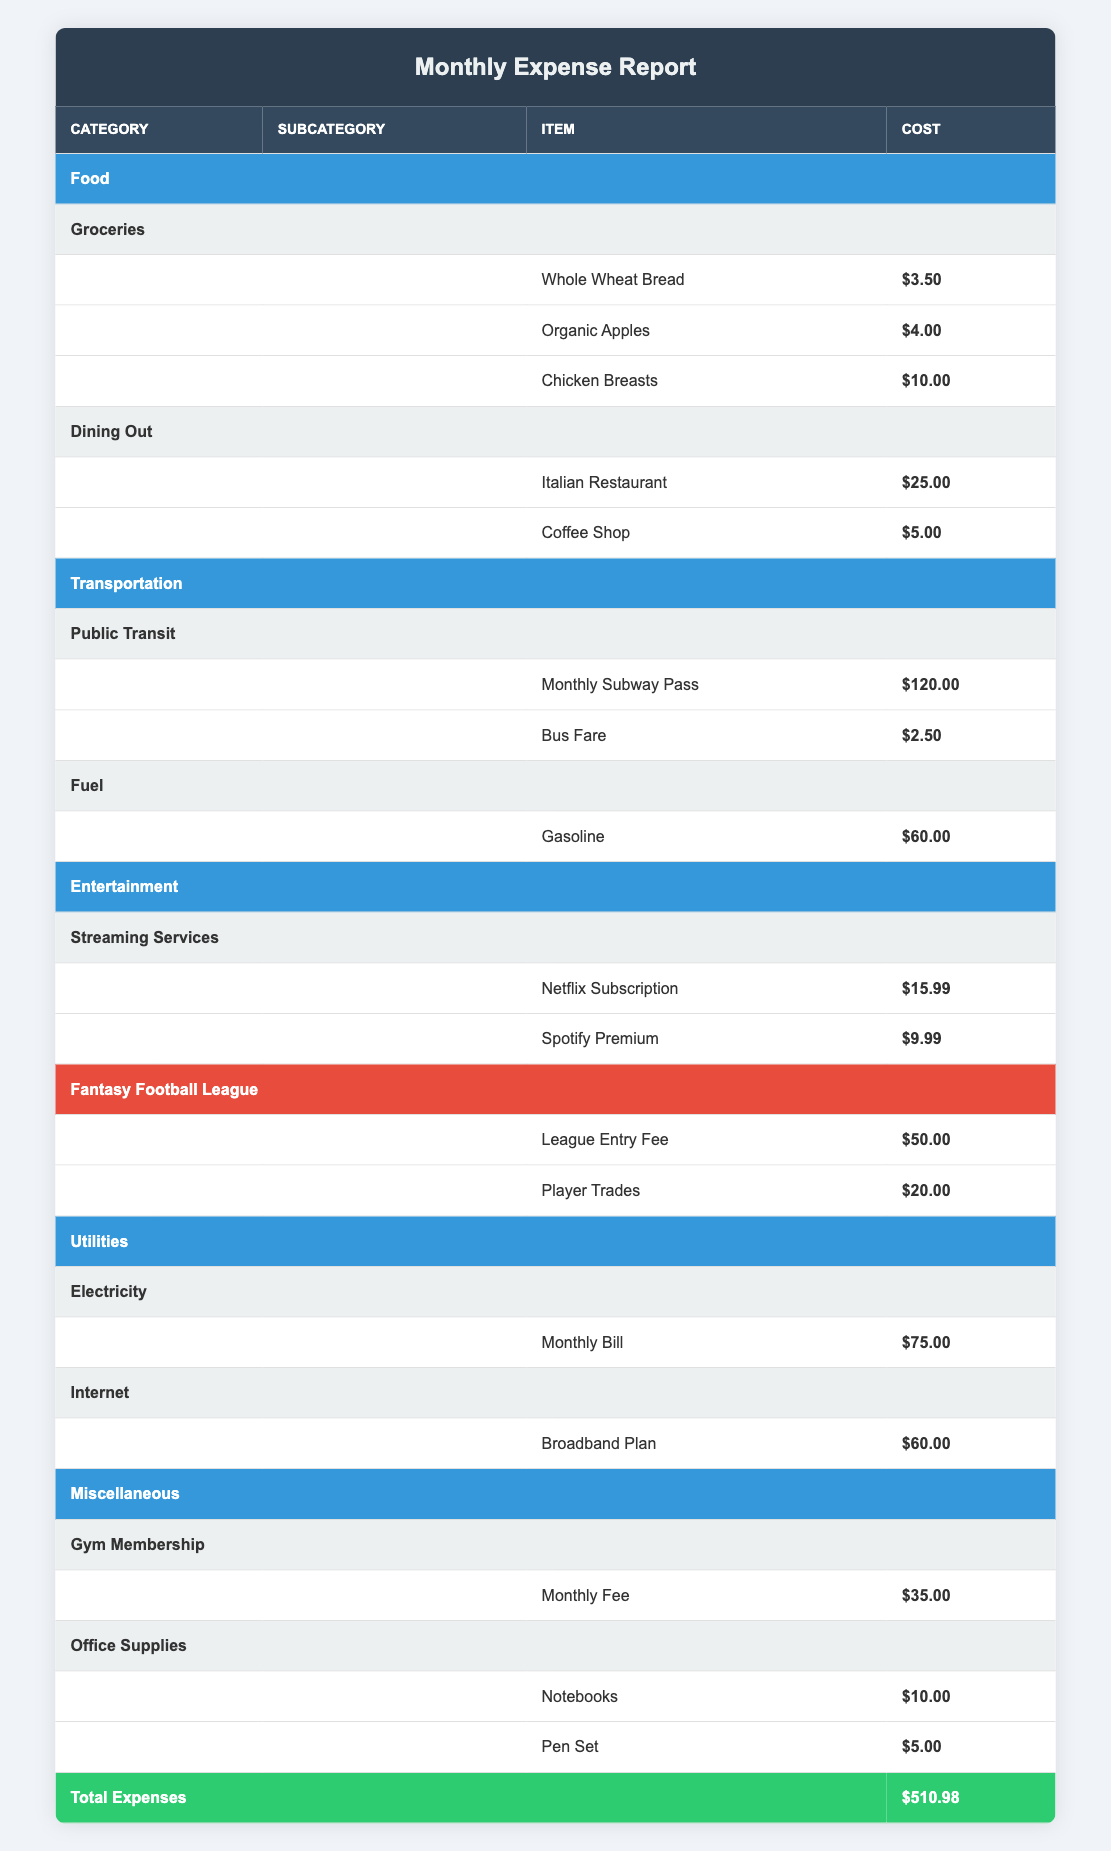What is the total cost of groceries? To find the total cost of groceries, we add the costs of each item in the Groceries subcategory: Whole Wheat Bread ($3.50) + Organic Apples ($4.00) + Chicken Breasts ($10.00) = $17.50.
Answer: $17.50 What is the cost of the Monthly Subway Pass? The Monthly Subway Pass is listed in the Public Transit subcategory under Transportation, with a cost of $120.00.
Answer: $120.00 Are there any costs for Gym Membership? Yes, there is a cost associated with Gym Membership. The Monthly Fee is listed as $35.00.
Answer: Yes What is the total spending on Entertainment? To calculate total spending on Entertainment, we need to sum the costs in both subcategories: Streaming Services ($15.99 + $9.99 = $25.98) and Fantasy Football League ($50.00 + $20.00 = $70.00). Then total is $25.98 + $70.00 = $95.98.
Answer: $95.98 What is the most expensive item in the table? The most expensive item can be identified by checking each cost. The Monthly Subway Pass is $120.00, which is higher than any other item listed.
Answer: $120.00 How much did you spend in the Miscellaneous category? The total spending in Miscellaneous can be calculated by adding the costs in the Gym Membership ($35.00) and Office Supplies ($10.00 + $5.00 = $15.00) subcategories: $35.00 + $15.00 = $50.00.
Answer: $50.00 Did you spend more on Food than on Utilities? Total spending on Food is $17.50 (Groceries) + $30.00 (Dining Out) = $47.50, and for Utilities, it is $75.00 (Electricity) + $60.00 (Internet) = $135.00. Since $47.50 is less than $135.00, the answer is no.
Answer: No What is the average cost of all office supplies? There are two items under Office Supplies: Notebooks ($10.00) and Pen Set ($5.00), making the total $15.00. To find the average, we divide this total by the number of items: $15.00 / 2 = $7.50.
Answer: $7.50 How much was spent on player trades versus the league entry fee? The cost of player trades is $20.00 and the league entry fee is $50.00. To compare, we see that $50.00 is the larger amount, meaning the league entry fee is higher than player trades by $30.00.
Answer: $30.00 more What is the total of the monthly expenses reported? The total of all expenses in the table is clearly indicated as $510.98 in the total expenses row. This is the overall sum of all category expenses.
Answer: $510.98 